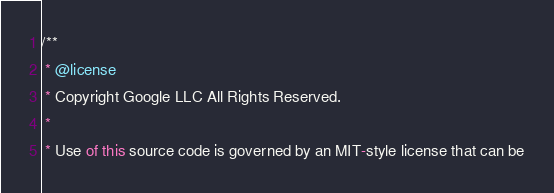Convert code to text. <code><loc_0><loc_0><loc_500><loc_500><_TypeScript_>/**
 * @license
 * Copyright Google LLC All Rights Reserved.
 *
 * Use of this source code is governed by an MIT-style license that can be</code> 